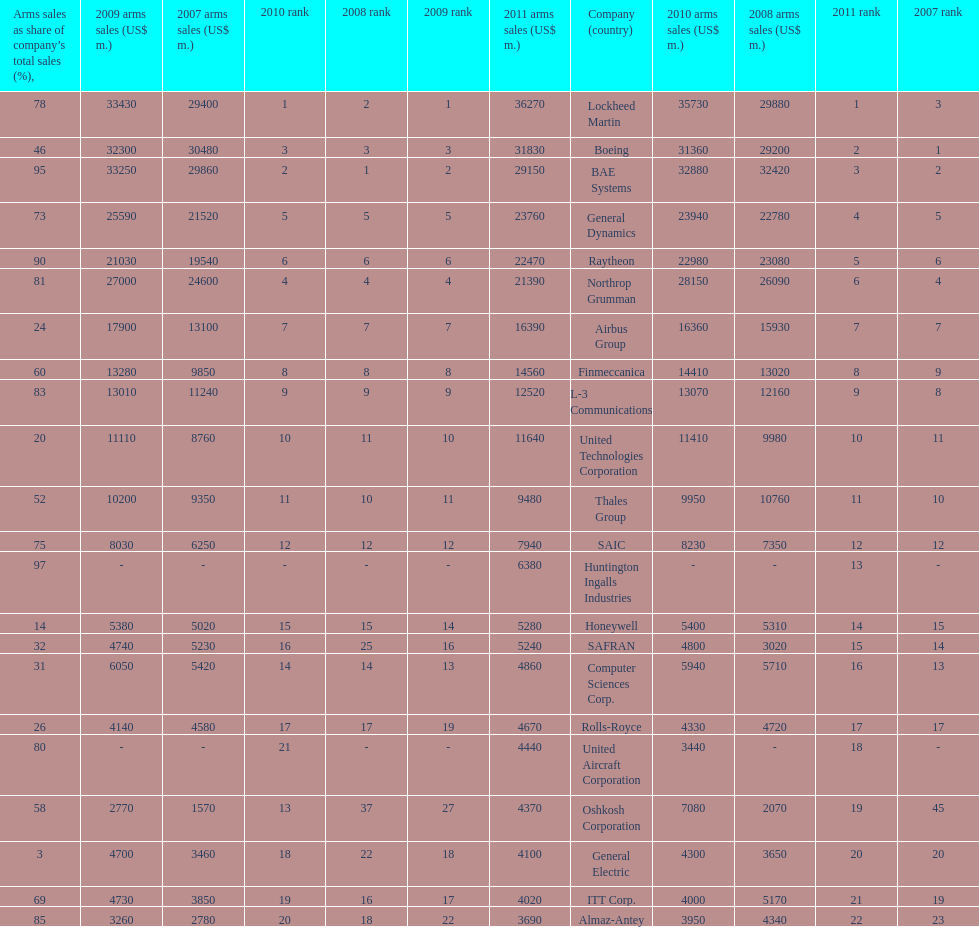How many different countries are listed? 6. 